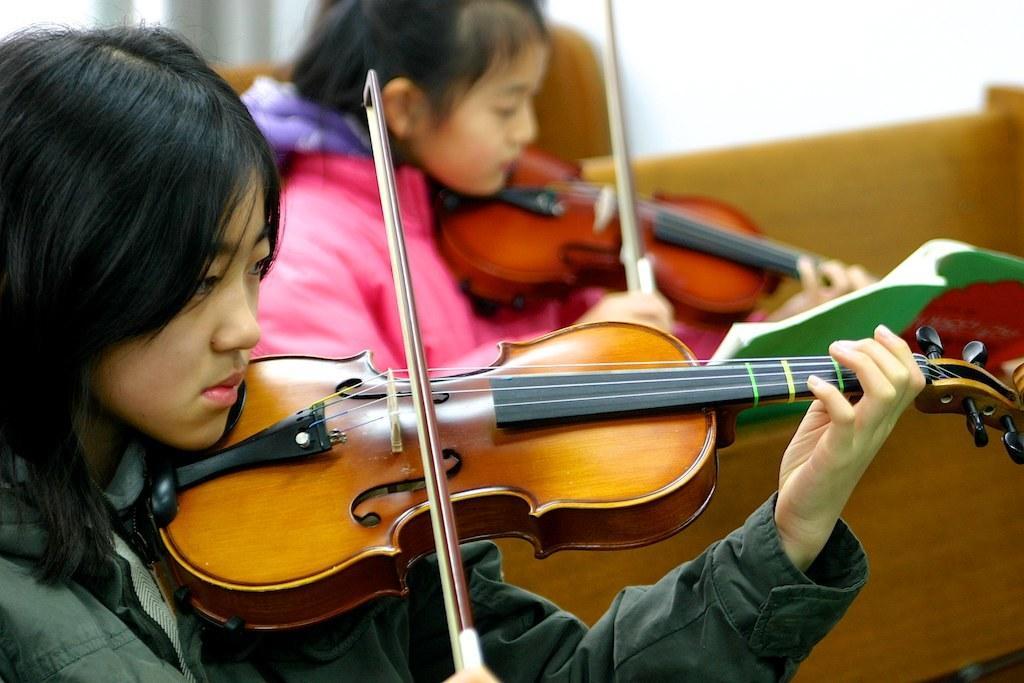How many people are in the image? There are two persons in the image. What are the two persons doing in the image? The two persons are playing a musical instrument. How are they playing the musical instrument? The musical instrument is being held in their hands. What type of sponge is being used to play the musical instrument in the image? There is no sponge present in the image; the musical instrument is being played by holding it in their hands. 